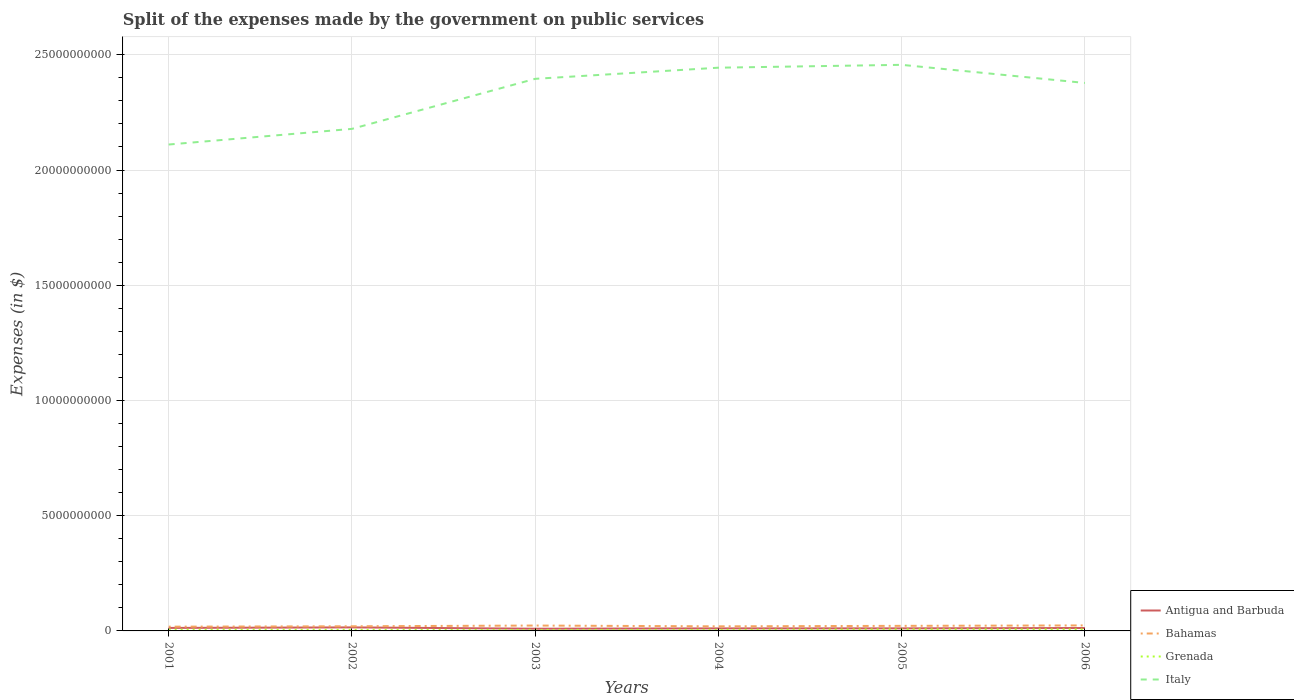Does the line corresponding to Grenada intersect with the line corresponding to Bahamas?
Offer a very short reply. No. Is the number of lines equal to the number of legend labels?
Offer a terse response. Yes. Across all years, what is the maximum expenses made by the government on public services in Grenada?
Offer a terse response. 4.05e+07. In which year was the expenses made by the government on public services in Italy maximum?
Give a very brief answer. 2001. What is the total expenses made by the government on public services in Bahamas in the graph?
Make the answer very short. -1.86e+07. What is the difference between the highest and the second highest expenses made by the government on public services in Antigua and Barbuda?
Your answer should be compact. 5.72e+07. Where does the legend appear in the graph?
Make the answer very short. Bottom right. How are the legend labels stacked?
Offer a very short reply. Vertical. What is the title of the graph?
Give a very brief answer. Split of the expenses made by the government on public services. Does "Lithuania" appear as one of the legend labels in the graph?
Offer a terse response. No. What is the label or title of the X-axis?
Make the answer very short. Years. What is the label or title of the Y-axis?
Ensure brevity in your answer.  Expenses (in $). What is the Expenses (in $) in Antigua and Barbuda in 2001?
Offer a terse response. 1.30e+08. What is the Expenses (in $) in Bahamas in 2001?
Keep it short and to the point. 1.85e+08. What is the Expenses (in $) in Grenada in 2001?
Your answer should be very brief. 5.26e+07. What is the Expenses (in $) in Italy in 2001?
Your answer should be compact. 2.11e+1. What is the Expenses (in $) in Antigua and Barbuda in 2002?
Your answer should be compact. 1.53e+08. What is the Expenses (in $) in Bahamas in 2002?
Keep it short and to the point. 2.02e+08. What is the Expenses (in $) of Grenada in 2002?
Make the answer very short. 4.75e+07. What is the Expenses (in $) of Italy in 2002?
Provide a succinct answer. 2.18e+1. What is the Expenses (in $) of Antigua and Barbuda in 2003?
Keep it short and to the point. 9.59e+07. What is the Expenses (in $) in Bahamas in 2003?
Offer a very short reply. 2.33e+08. What is the Expenses (in $) in Grenada in 2003?
Your response must be concise. 4.05e+07. What is the Expenses (in $) of Italy in 2003?
Offer a terse response. 2.40e+1. What is the Expenses (in $) in Antigua and Barbuda in 2004?
Your answer should be very brief. 1.10e+08. What is the Expenses (in $) of Bahamas in 2004?
Your answer should be very brief. 1.99e+08. What is the Expenses (in $) of Grenada in 2004?
Keep it short and to the point. 4.61e+07. What is the Expenses (in $) in Italy in 2004?
Keep it short and to the point. 2.44e+1. What is the Expenses (in $) in Antigua and Barbuda in 2005?
Provide a succinct answer. 1.11e+08. What is the Expenses (in $) in Bahamas in 2005?
Offer a very short reply. 2.20e+08. What is the Expenses (in $) in Grenada in 2005?
Offer a very short reply. 6.79e+07. What is the Expenses (in $) of Italy in 2005?
Your response must be concise. 2.46e+1. What is the Expenses (in $) of Antigua and Barbuda in 2006?
Ensure brevity in your answer.  1.26e+08. What is the Expenses (in $) of Bahamas in 2006?
Ensure brevity in your answer.  2.39e+08. What is the Expenses (in $) of Grenada in 2006?
Ensure brevity in your answer.  6.61e+07. What is the Expenses (in $) of Italy in 2006?
Ensure brevity in your answer.  2.38e+1. Across all years, what is the maximum Expenses (in $) in Antigua and Barbuda?
Ensure brevity in your answer.  1.53e+08. Across all years, what is the maximum Expenses (in $) of Bahamas?
Provide a succinct answer. 2.39e+08. Across all years, what is the maximum Expenses (in $) in Grenada?
Provide a succinct answer. 6.79e+07. Across all years, what is the maximum Expenses (in $) in Italy?
Offer a very short reply. 2.46e+1. Across all years, what is the minimum Expenses (in $) of Antigua and Barbuda?
Provide a short and direct response. 9.59e+07. Across all years, what is the minimum Expenses (in $) of Bahamas?
Your response must be concise. 1.85e+08. Across all years, what is the minimum Expenses (in $) of Grenada?
Provide a short and direct response. 4.05e+07. Across all years, what is the minimum Expenses (in $) of Italy?
Your response must be concise. 2.11e+1. What is the total Expenses (in $) in Antigua and Barbuda in the graph?
Provide a short and direct response. 7.26e+08. What is the total Expenses (in $) in Bahamas in the graph?
Your answer should be compact. 1.28e+09. What is the total Expenses (in $) of Grenada in the graph?
Keep it short and to the point. 3.21e+08. What is the total Expenses (in $) in Italy in the graph?
Give a very brief answer. 1.40e+11. What is the difference between the Expenses (in $) in Antigua and Barbuda in 2001 and that in 2002?
Give a very brief answer. -2.31e+07. What is the difference between the Expenses (in $) in Bahamas in 2001 and that in 2002?
Your response must be concise. -1.67e+07. What is the difference between the Expenses (in $) of Grenada in 2001 and that in 2002?
Give a very brief answer. 5.10e+06. What is the difference between the Expenses (in $) in Italy in 2001 and that in 2002?
Make the answer very short. -6.79e+08. What is the difference between the Expenses (in $) of Antigua and Barbuda in 2001 and that in 2003?
Your answer should be compact. 3.41e+07. What is the difference between the Expenses (in $) in Bahamas in 2001 and that in 2003?
Provide a short and direct response. -4.84e+07. What is the difference between the Expenses (in $) in Grenada in 2001 and that in 2003?
Your answer should be very brief. 1.21e+07. What is the difference between the Expenses (in $) in Italy in 2001 and that in 2003?
Offer a terse response. -2.85e+09. What is the difference between the Expenses (in $) of Antigua and Barbuda in 2001 and that in 2004?
Your response must be concise. 2.01e+07. What is the difference between the Expenses (in $) in Bahamas in 2001 and that in 2004?
Provide a succinct answer. -1.43e+07. What is the difference between the Expenses (in $) of Grenada in 2001 and that in 2004?
Your answer should be very brief. 6.50e+06. What is the difference between the Expenses (in $) in Italy in 2001 and that in 2004?
Your answer should be compact. -3.33e+09. What is the difference between the Expenses (in $) in Antigua and Barbuda in 2001 and that in 2005?
Your response must be concise. 1.90e+07. What is the difference between the Expenses (in $) in Bahamas in 2001 and that in 2005?
Make the answer very short. -3.53e+07. What is the difference between the Expenses (in $) of Grenada in 2001 and that in 2005?
Make the answer very short. -1.53e+07. What is the difference between the Expenses (in $) in Italy in 2001 and that in 2005?
Offer a terse response. -3.46e+09. What is the difference between the Expenses (in $) in Antigua and Barbuda in 2001 and that in 2006?
Offer a terse response. 3.80e+06. What is the difference between the Expenses (in $) in Bahamas in 2001 and that in 2006?
Offer a very short reply. -5.38e+07. What is the difference between the Expenses (in $) in Grenada in 2001 and that in 2006?
Your answer should be very brief. -1.35e+07. What is the difference between the Expenses (in $) in Italy in 2001 and that in 2006?
Make the answer very short. -2.67e+09. What is the difference between the Expenses (in $) in Antigua and Barbuda in 2002 and that in 2003?
Provide a short and direct response. 5.72e+07. What is the difference between the Expenses (in $) of Bahamas in 2002 and that in 2003?
Make the answer very short. -3.17e+07. What is the difference between the Expenses (in $) of Grenada in 2002 and that in 2003?
Ensure brevity in your answer.  7.00e+06. What is the difference between the Expenses (in $) of Italy in 2002 and that in 2003?
Your answer should be compact. -2.17e+09. What is the difference between the Expenses (in $) of Antigua and Barbuda in 2002 and that in 2004?
Keep it short and to the point. 4.32e+07. What is the difference between the Expenses (in $) of Bahamas in 2002 and that in 2004?
Your answer should be very brief. 2.43e+06. What is the difference between the Expenses (in $) of Grenada in 2002 and that in 2004?
Ensure brevity in your answer.  1.40e+06. What is the difference between the Expenses (in $) of Italy in 2002 and that in 2004?
Your response must be concise. -2.66e+09. What is the difference between the Expenses (in $) in Antigua and Barbuda in 2002 and that in 2005?
Provide a short and direct response. 4.21e+07. What is the difference between the Expenses (in $) in Bahamas in 2002 and that in 2005?
Your answer should be very brief. -1.86e+07. What is the difference between the Expenses (in $) of Grenada in 2002 and that in 2005?
Keep it short and to the point. -2.04e+07. What is the difference between the Expenses (in $) in Italy in 2002 and that in 2005?
Offer a terse response. -2.78e+09. What is the difference between the Expenses (in $) of Antigua and Barbuda in 2002 and that in 2006?
Offer a terse response. 2.69e+07. What is the difference between the Expenses (in $) in Bahamas in 2002 and that in 2006?
Your response must be concise. -3.71e+07. What is the difference between the Expenses (in $) in Grenada in 2002 and that in 2006?
Ensure brevity in your answer.  -1.86e+07. What is the difference between the Expenses (in $) of Italy in 2002 and that in 2006?
Provide a short and direct response. -1.99e+09. What is the difference between the Expenses (in $) of Antigua and Barbuda in 2003 and that in 2004?
Your response must be concise. -1.40e+07. What is the difference between the Expenses (in $) in Bahamas in 2003 and that in 2004?
Offer a terse response. 3.41e+07. What is the difference between the Expenses (in $) in Grenada in 2003 and that in 2004?
Your answer should be very brief. -5.60e+06. What is the difference between the Expenses (in $) in Italy in 2003 and that in 2004?
Offer a very short reply. -4.83e+08. What is the difference between the Expenses (in $) in Antigua and Barbuda in 2003 and that in 2005?
Give a very brief answer. -1.51e+07. What is the difference between the Expenses (in $) of Bahamas in 2003 and that in 2005?
Your response must be concise. 1.31e+07. What is the difference between the Expenses (in $) of Grenada in 2003 and that in 2005?
Ensure brevity in your answer.  -2.74e+07. What is the difference between the Expenses (in $) in Italy in 2003 and that in 2005?
Offer a very short reply. -6.07e+08. What is the difference between the Expenses (in $) in Antigua and Barbuda in 2003 and that in 2006?
Keep it short and to the point. -3.03e+07. What is the difference between the Expenses (in $) in Bahamas in 2003 and that in 2006?
Your response must be concise. -5.39e+06. What is the difference between the Expenses (in $) of Grenada in 2003 and that in 2006?
Make the answer very short. -2.56e+07. What is the difference between the Expenses (in $) of Italy in 2003 and that in 2006?
Keep it short and to the point. 1.79e+08. What is the difference between the Expenses (in $) in Antigua and Barbuda in 2004 and that in 2005?
Give a very brief answer. -1.10e+06. What is the difference between the Expenses (in $) of Bahamas in 2004 and that in 2005?
Make the answer very short. -2.10e+07. What is the difference between the Expenses (in $) of Grenada in 2004 and that in 2005?
Your answer should be very brief. -2.18e+07. What is the difference between the Expenses (in $) in Italy in 2004 and that in 2005?
Make the answer very short. -1.24e+08. What is the difference between the Expenses (in $) of Antigua and Barbuda in 2004 and that in 2006?
Ensure brevity in your answer.  -1.63e+07. What is the difference between the Expenses (in $) in Bahamas in 2004 and that in 2006?
Ensure brevity in your answer.  -3.95e+07. What is the difference between the Expenses (in $) in Grenada in 2004 and that in 2006?
Your answer should be compact. -2.00e+07. What is the difference between the Expenses (in $) in Italy in 2004 and that in 2006?
Your response must be concise. 6.62e+08. What is the difference between the Expenses (in $) in Antigua and Barbuda in 2005 and that in 2006?
Give a very brief answer. -1.52e+07. What is the difference between the Expenses (in $) of Bahamas in 2005 and that in 2006?
Your answer should be compact. -1.85e+07. What is the difference between the Expenses (in $) in Grenada in 2005 and that in 2006?
Your answer should be compact. 1.80e+06. What is the difference between the Expenses (in $) of Italy in 2005 and that in 2006?
Provide a short and direct response. 7.86e+08. What is the difference between the Expenses (in $) in Antigua and Barbuda in 2001 and the Expenses (in $) in Bahamas in 2002?
Your answer should be compact. -7.15e+07. What is the difference between the Expenses (in $) in Antigua and Barbuda in 2001 and the Expenses (in $) in Grenada in 2002?
Provide a succinct answer. 8.25e+07. What is the difference between the Expenses (in $) in Antigua and Barbuda in 2001 and the Expenses (in $) in Italy in 2002?
Ensure brevity in your answer.  -2.17e+1. What is the difference between the Expenses (in $) in Bahamas in 2001 and the Expenses (in $) in Grenada in 2002?
Provide a succinct answer. 1.37e+08. What is the difference between the Expenses (in $) of Bahamas in 2001 and the Expenses (in $) of Italy in 2002?
Your answer should be very brief. -2.16e+1. What is the difference between the Expenses (in $) of Grenada in 2001 and the Expenses (in $) of Italy in 2002?
Offer a very short reply. -2.17e+1. What is the difference between the Expenses (in $) of Antigua and Barbuda in 2001 and the Expenses (in $) of Bahamas in 2003?
Offer a very short reply. -1.03e+08. What is the difference between the Expenses (in $) of Antigua and Barbuda in 2001 and the Expenses (in $) of Grenada in 2003?
Provide a short and direct response. 8.95e+07. What is the difference between the Expenses (in $) of Antigua and Barbuda in 2001 and the Expenses (in $) of Italy in 2003?
Your answer should be very brief. -2.38e+1. What is the difference between the Expenses (in $) in Bahamas in 2001 and the Expenses (in $) in Grenada in 2003?
Offer a very short reply. 1.44e+08. What is the difference between the Expenses (in $) in Bahamas in 2001 and the Expenses (in $) in Italy in 2003?
Offer a terse response. -2.38e+1. What is the difference between the Expenses (in $) of Grenada in 2001 and the Expenses (in $) of Italy in 2003?
Your answer should be very brief. -2.39e+1. What is the difference between the Expenses (in $) of Antigua and Barbuda in 2001 and the Expenses (in $) of Bahamas in 2004?
Your response must be concise. -6.91e+07. What is the difference between the Expenses (in $) in Antigua and Barbuda in 2001 and the Expenses (in $) in Grenada in 2004?
Your response must be concise. 8.39e+07. What is the difference between the Expenses (in $) of Antigua and Barbuda in 2001 and the Expenses (in $) of Italy in 2004?
Ensure brevity in your answer.  -2.43e+1. What is the difference between the Expenses (in $) in Bahamas in 2001 and the Expenses (in $) in Grenada in 2004?
Ensure brevity in your answer.  1.39e+08. What is the difference between the Expenses (in $) in Bahamas in 2001 and the Expenses (in $) in Italy in 2004?
Ensure brevity in your answer.  -2.43e+1. What is the difference between the Expenses (in $) in Grenada in 2001 and the Expenses (in $) in Italy in 2004?
Keep it short and to the point. -2.44e+1. What is the difference between the Expenses (in $) of Antigua and Barbuda in 2001 and the Expenses (in $) of Bahamas in 2005?
Offer a terse response. -9.01e+07. What is the difference between the Expenses (in $) of Antigua and Barbuda in 2001 and the Expenses (in $) of Grenada in 2005?
Keep it short and to the point. 6.21e+07. What is the difference between the Expenses (in $) in Antigua and Barbuda in 2001 and the Expenses (in $) in Italy in 2005?
Your answer should be compact. -2.44e+1. What is the difference between the Expenses (in $) of Bahamas in 2001 and the Expenses (in $) of Grenada in 2005?
Make the answer very short. 1.17e+08. What is the difference between the Expenses (in $) in Bahamas in 2001 and the Expenses (in $) in Italy in 2005?
Offer a terse response. -2.44e+1. What is the difference between the Expenses (in $) of Grenada in 2001 and the Expenses (in $) of Italy in 2005?
Offer a terse response. -2.45e+1. What is the difference between the Expenses (in $) in Antigua and Barbuda in 2001 and the Expenses (in $) in Bahamas in 2006?
Your answer should be very brief. -1.09e+08. What is the difference between the Expenses (in $) in Antigua and Barbuda in 2001 and the Expenses (in $) in Grenada in 2006?
Give a very brief answer. 6.39e+07. What is the difference between the Expenses (in $) of Antigua and Barbuda in 2001 and the Expenses (in $) of Italy in 2006?
Keep it short and to the point. -2.36e+1. What is the difference between the Expenses (in $) of Bahamas in 2001 and the Expenses (in $) of Grenada in 2006?
Provide a short and direct response. 1.19e+08. What is the difference between the Expenses (in $) of Bahamas in 2001 and the Expenses (in $) of Italy in 2006?
Keep it short and to the point. -2.36e+1. What is the difference between the Expenses (in $) in Grenada in 2001 and the Expenses (in $) in Italy in 2006?
Make the answer very short. -2.37e+1. What is the difference between the Expenses (in $) of Antigua and Barbuda in 2002 and the Expenses (in $) of Bahamas in 2003?
Your answer should be compact. -8.01e+07. What is the difference between the Expenses (in $) in Antigua and Barbuda in 2002 and the Expenses (in $) in Grenada in 2003?
Ensure brevity in your answer.  1.13e+08. What is the difference between the Expenses (in $) in Antigua and Barbuda in 2002 and the Expenses (in $) in Italy in 2003?
Provide a short and direct response. -2.38e+1. What is the difference between the Expenses (in $) of Bahamas in 2002 and the Expenses (in $) of Grenada in 2003?
Your answer should be very brief. 1.61e+08. What is the difference between the Expenses (in $) of Bahamas in 2002 and the Expenses (in $) of Italy in 2003?
Make the answer very short. -2.38e+1. What is the difference between the Expenses (in $) in Grenada in 2002 and the Expenses (in $) in Italy in 2003?
Provide a succinct answer. -2.39e+1. What is the difference between the Expenses (in $) in Antigua and Barbuda in 2002 and the Expenses (in $) in Bahamas in 2004?
Your answer should be compact. -4.60e+07. What is the difference between the Expenses (in $) of Antigua and Barbuda in 2002 and the Expenses (in $) of Grenada in 2004?
Your response must be concise. 1.07e+08. What is the difference between the Expenses (in $) in Antigua and Barbuda in 2002 and the Expenses (in $) in Italy in 2004?
Provide a short and direct response. -2.43e+1. What is the difference between the Expenses (in $) in Bahamas in 2002 and the Expenses (in $) in Grenada in 2004?
Your response must be concise. 1.55e+08. What is the difference between the Expenses (in $) in Bahamas in 2002 and the Expenses (in $) in Italy in 2004?
Keep it short and to the point. -2.42e+1. What is the difference between the Expenses (in $) in Grenada in 2002 and the Expenses (in $) in Italy in 2004?
Your answer should be compact. -2.44e+1. What is the difference between the Expenses (in $) in Antigua and Barbuda in 2002 and the Expenses (in $) in Bahamas in 2005?
Your response must be concise. -6.70e+07. What is the difference between the Expenses (in $) of Antigua and Barbuda in 2002 and the Expenses (in $) of Grenada in 2005?
Provide a succinct answer. 8.52e+07. What is the difference between the Expenses (in $) in Antigua and Barbuda in 2002 and the Expenses (in $) in Italy in 2005?
Provide a succinct answer. -2.44e+1. What is the difference between the Expenses (in $) of Bahamas in 2002 and the Expenses (in $) of Grenada in 2005?
Ensure brevity in your answer.  1.34e+08. What is the difference between the Expenses (in $) of Bahamas in 2002 and the Expenses (in $) of Italy in 2005?
Offer a very short reply. -2.44e+1. What is the difference between the Expenses (in $) in Grenada in 2002 and the Expenses (in $) in Italy in 2005?
Make the answer very short. -2.45e+1. What is the difference between the Expenses (in $) in Antigua and Barbuda in 2002 and the Expenses (in $) in Bahamas in 2006?
Provide a succinct answer. -8.55e+07. What is the difference between the Expenses (in $) of Antigua and Barbuda in 2002 and the Expenses (in $) of Grenada in 2006?
Your answer should be compact. 8.70e+07. What is the difference between the Expenses (in $) in Antigua and Barbuda in 2002 and the Expenses (in $) in Italy in 2006?
Offer a terse response. -2.36e+1. What is the difference between the Expenses (in $) in Bahamas in 2002 and the Expenses (in $) in Grenada in 2006?
Provide a succinct answer. 1.35e+08. What is the difference between the Expenses (in $) of Bahamas in 2002 and the Expenses (in $) of Italy in 2006?
Provide a short and direct response. -2.36e+1. What is the difference between the Expenses (in $) of Grenada in 2002 and the Expenses (in $) of Italy in 2006?
Offer a terse response. -2.37e+1. What is the difference between the Expenses (in $) of Antigua and Barbuda in 2003 and the Expenses (in $) of Bahamas in 2004?
Offer a terse response. -1.03e+08. What is the difference between the Expenses (in $) in Antigua and Barbuda in 2003 and the Expenses (in $) in Grenada in 2004?
Offer a terse response. 4.98e+07. What is the difference between the Expenses (in $) of Antigua and Barbuda in 2003 and the Expenses (in $) of Italy in 2004?
Offer a terse response. -2.43e+1. What is the difference between the Expenses (in $) of Bahamas in 2003 and the Expenses (in $) of Grenada in 2004?
Your response must be concise. 1.87e+08. What is the difference between the Expenses (in $) in Bahamas in 2003 and the Expenses (in $) in Italy in 2004?
Your answer should be very brief. -2.42e+1. What is the difference between the Expenses (in $) in Grenada in 2003 and the Expenses (in $) in Italy in 2004?
Provide a succinct answer. -2.44e+1. What is the difference between the Expenses (in $) in Antigua and Barbuda in 2003 and the Expenses (in $) in Bahamas in 2005?
Your answer should be very brief. -1.24e+08. What is the difference between the Expenses (in $) of Antigua and Barbuda in 2003 and the Expenses (in $) of Grenada in 2005?
Offer a very short reply. 2.80e+07. What is the difference between the Expenses (in $) in Antigua and Barbuda in 2003 and the Expenses (in $) in Italy in 2005?
Your response must be concise. -2.45e+1. What is the difference between the Expenses (in $) of Bahamas in 2003 and the Expenses (in $) of Grenada in 2005?
Make the answer very short. 1.65e+08. What is the difference between the Expenses (in $) of Bahamas in 2003 and the Expenses (in $) of Italy in 2005?
Ensure brevity in your answer.  -2.43e+1. What is the difference between the Expenses (in $) in Grenada in 2003 and the Expenses (in $) in Italy in 2005?
Your response must be concise. -2.45e+1. What is the difference between the Expenses (in $) in Antigua and Barbuda in 2003 and the Expenses (in $) in Bahamas in 2006?
Your response must be concise. -1.43e+08. What is the difference between the Expenses (in $) in Antigua and Barbuda in 2003 and the Expenses (in $) in Grenada in 2006?
Make the answer very short. 2.98e+07. What is the difference between the Expenses (in $) of Antigua and Barbuda in 2003 and the Expenses (in $) of Italy in 2006?
Your answer should be compact. -2.37e+1. What is the difference between the Expenses (in $) in Bahamas in 2003 and the Expenses (in $) in Grenada in 2006?
Keep it short and to the point. 1.67e+08. What is the difference between the Expenses (in $) in Bahamas in 2003 and the Expenses (in $) in Italy in 2006?
Offer a very short reply. -2.35e+1. What is the difference between the Expenses (in $) in Grenada in 2003 and the Expenses (in $) in Italy in 2006?
Offer a very short reply. -2.37e+1. What is the difference between the Expenses (in $) of Antigua and Barbuda in 2004 and the Expenses (in $) of Bahamas in 2005?
Your answer should be very brief. -1.10e+08. What is the difference between the Expenses (in $) in Antigua and Barbuda in 2004 and the Expenses (in $) in Grenada in 2005?
Your response must be concise. 4.20e+07. What is the difference between the Expenses (in $) in Antigua and Barbuda in 2004 and the Expenses (in $) in Italy in 2005?
Give a very brief answer. -2.45e+1. What is the difference between the Expenses (in $) in Bahamas in 2004 and the Expenses (in $) in Grenada in 2005?
Your answer should be compact. 1.31e+08. What is the difference between the Expenses (in $) of Bahamas in 2004 and the Expenses (in $) of Italy in 2005?
Provide a short and direct response. -2.44e+1. What is the difference between the Expenses (in $) of Grenada in 2004 and the Expenses (in $) of Italy in 2005?
Ensure brevity in your answer.  -2.45e+1. What is the difference between the Expenses (in $) in Antigua and Barbuda in 2004 and the Expenses (in $) in Bahamas in 2006?
Provide a short and direct response. -1.29e+08. What is the difference between the Expenses (in $) in Antigua and Barbuda in 2004 and the Expenses (in $) in Grenada in 2006?
Provide a succinct answer. 4.38e+07. What is the difference between the Expenses (in $) in Antigua and Barbuda in 2004 and the Expenses (in $) in Italy in 2006?
Provide a short and direct response. -2.37e+1. What is the difference between the Expenses (in $) of Bahamas in 2004 and the Expenses (in $) of Grenada in 2006?
Offer a terse response. 1.33e+08. What is the difference between the Expenses (in $) in Bahamas in 2004 and the Expenses (in $) in Italy in 2006?
Ensure brevity in your answer.  -2.36e+1. What is the difference between the Expenses (in $) in Grenada in 2004 and the Expenses (in $) in Italy in 2006?
Provide a short and direct response. -2.37e+1. What is the difference between the Expenses (in $) of Antigua and Barbuda in 2005 and the Expenses (in $) of Bahamas in 2006?
Offer a very short reply. -1.28e+08. What is the difference between the Expenses (in $) in Antigua and Barbuda in 2005 and the Expenses (in $) in Grenada in 2006?
Make the answer very short. 4.49e+07. What is the difference between the Expenses (in $) in Antigua and Barbuda in 2005 and the Expenses (in $) in Italy in 2006?
Ensure brevity in your answer.  -2.37e+1. What is the difference between the Expenses (in $) of Bahamas in 2005 and the Expenses (in $) of Grenada in 2006?
Keep it short and to the point. 1.54e+08. What is the difference between the Expenses (in $) in Bahamas in 2005 and the Expenses (in $) in Italy in 2006?
Offer a terse response. -2.36e+1. What is the difference between the Expenses (in $) in Grenada in 2005 and the Expenses (in $) in Italy in 2006?
Your answer should be compact. -2.37e+1. What is the average Expenses (in $) of Antigua and Barbuda per year?
Provide a succinct answer. 1.21e+08. What is the average Expenses (in $) in Bahamas per year?
Offer a very short reply. 2.13e+08. What is the average Expenses (in $) in Grenada per year?
Keep it short and to the point. 5.34e+07. What is the average Expenses (in $) of Italy per year?
Ensure brevity in your answer.  2.33e+1. In the year 2001, what is the difference between the Expenses (in $) of Antigua and Barbuda and Expenses (in $) of Bahamas?
Provide a succinct answer. -5.48e+07. In the year 2001, what is the difference between the Expenses (in $) in Antigua and Barbuda and Expenses (in $) in Grenada?
Your answer should be very brief. 7.74e+07. In the year 2001, what is the difference between the Expenses (in $) of Antigua and Barbuda and Expenses (in $) of Italy?
Provide a succinct answer. -2.10e+1. In the year 2001, what is the difference between the Expenses (in $) of Bahamas and Expenses (in $) of Grenada?
Give a very brief answer. 1.32e+08. In the year 2001, what is the difference between the Expenses (in $) of Bahamas and Expenses (in $) of Italy?
Make the answer very short. -2.09e+1. In the year 2001, what is the difference between the Expenses (in $) of Grenada and Expenses (in $) of Italy?
Give a very brief answer. -2.11e+1. In the year 2002, what is the difference between the Expenses (in $) in Antigua and Barbuda and Expenses (in $) in Bahamas?
Ensure brevity in your answer.  -4.84e+07. In the year 2002, what is the difference between the Expenses (in $) in Antigua and Barbuda and Expenses (in $) in Grenada?
Provide a succinct answer. 1.06e+08. In the year 2002, what is the difference between the Expenses (in $) of Antigua and Barbuda and Expenses (in $) of Italy?
Offer a terse response. -2.16e+1. In the year 2002, what is the difference between the Expenses (in $) in Bahamas and Expenses (in $) in Grenada?
Provide a short and direct response. 1.54e+08. In the year 2002, what is the difference between the Expenses (in $) in Bahamas and Expenses (in $) in Italy?
Keep it short and to the point. -2.16e+1. In the year 2002, what is the difference between the Expenses (in $) of Grenada and Expenses (in $) of Italy?
Offer a very short reply. -2.17e+1. In the year 2003, what is the difference between the Expenses (in $) of Antigua and Barbuda and Expenses (in $) of Bahamas?
Your response must be concise. -1.37e+08. In the year 2003, what is the difference between the Expenses (in $) of Antigua and Barbuda and Expenses (in $) of Grenada?
Offer a terse response. 5.54e+07. In the year 2003, what is the difference between the Expenses (in $) of Antigua and Barbuda and Expenses (in $) of Italy?
Ensure brevity in your answer.  -2.39e+1. In the year 2003, what is the difference between the Expenses (in $) of Bahamas and Expenses (in $) of Grenada?
Ensure brevity in your answer.  1.93e+08. In the year 2003, what is the difference between the Expenses (in $) of Bahamas and Expenses (in $) of Italy?
Offer a very short reply. -2.37e+1. In the year 2003, what is the difference between the Expenses (in $) in Grenada and Expenses (in $) in Italy?
Offer a terse response. -2.39e+1. In the year 2004, what is the difference between the Expenses (in $) of Antigua and Barbuda and Expenses (in $) of Bahamas?
Keep it short and to the point. -8.92e+07. In the year 2004, what is the difference between the Expenses (in $) of Antigua and Barbuda and Expenses (in $) of Grenada?
Your answer should be very brief. 6.38e+07. In the year 2004, what is the difference between the Expenses (in $) in Antigua and Barbuda and Expenses (in $) in Italy?
Provide a succinct answer. -2.43e+1. In the year 2004, what is the difference between the Expenses (in $) in Bahamas and Expenses (in $) in Grenada?
Offer a very short reply. 1.53e+08. In the year 2004, what is the difference between the Expenses (in $) in Bahamas and Expenses (in $) in Italy?
Ensure brevity in your answer.  -2.42e+1. In the year 2004, what is the difference between the Expenses (in $) in Grenada and Expenses (in $) in Italy?
Offer a terse response. -2.44e+1. In the year 2005, what is the difference between the Expenses (in $) of Antigua and Barbuda and Expenses (in $) of Bahamas?
Make the answer very short. -1.09e+08. In the year 2005, what is the difference between the Expenses (in $) of Antigua and Barbuda and Expenses (in $) of Grenada?
Your response must be concise. 4.31e+07. In the year 2005, what is the difference between the Expenses (in $) of Antigua and Barbuda and Expenses (in $) of Italy?
Offer a terse response. -2.45e+1. In the year 2005, what is the difference between the Expenses (in $) of Bahamas and Expenses (in $) of Grenada?
Ensure brevity in your answer.  1.52e+08. In the year 2005, what is the difference between the Expenses (in $) in Bahamas and Expenses (in $) in Italy?
Ensure brevity in your answer.  -2.43e+1. In the year 2005, what is the difference between the Expenses (in $) in Grenada and Expenses (in $) in Italy?
Keep it short and to the point. -2.45e+1. In the year 2006, what is the difference between the Expenses (in $) of Antigua and Barbuda and Expenses (in $) of Bahamas?
Your answer should be compact. -1.12e+08. In the year 2006, what is the difference between the Expenses (in $) in Antigua and Barbuda and Expenses (in $) in Grenada?
Your response must be concise. 6.01e+07. In the year 2006, what is the difference between the Expenses (in $) in Antigua and Barbuda and Expenses (in $) in Italy?
Your response must be concise. -2.37e+1. In the year 2006, what is the difference between the Expenses (in $) of Bahamas and Expenses (in $) of Grenada?
Provide a short and direct response. 1.72e+08. In the year 2006, what is the difference between the Expenses (in $) of Bahamas and Expenses (in $) of Italy?
Give a very brief answer. -2.35e+1. In the year 2006, what is the difference between the Expenses (in $) in Grenada and Expenses (in $) in Italy?
Your answer should be very brief. -2.37e+1. What is the ratio of the Expenses (in $) of Antigua and Barbuda in 2001 to that in 2002?
Offer a very short reply. 0.85. What is the ratio of the Expenses (in $) in Bahamas in 2001 to that in 2002?
Make the answer very short. 0.92. What is the ratio of the Expenses (in $) in Grenada in 2001 to that in 2002?
Provide a succinct answer. 1.11. What is the ratio of the Expenses (in $) in Italy in 2001 to that in 2002?
Your answer should be compact. 0.97. What is the ratio of the Expenses (in $) of Antigua and Barbuda in 2001 to that in 2003?
Your answer should be very brief. 1.36. What is the ratio of the Expenses (in $) of Bahamas in 2001 to that in 2003?
Keep it short and to the point. 0.79. What is the ratio of the Expenses (in $) of Grenada in 2001 to that in 2003?
Keep it short and to the point. 1.3. What is the ratio of the Expenses (in $) of Italy in 2001 to that in 2003?
Your response must be concise. 0.88. What is the ratio of the Expenses (in $) in Antigua and Barbuda in 2001 to that in 2004?
Your answer should be very brief. 1.18. What is the ratio of the Expenses (in $) in Bahamas in 2001 to that in 2004?
Provide a succinct answer. 0.93. What is the ratio of the Expenses (in $) of Grenada in 2001 to that in 2004?
Your answer should be very brief. 1.14. What is the ratio of the Expenses (in $) in Italy in 2001 to that in 2004?
Give a very brief answer. 0.86. What is the ratio of the Expenses (in $) in Antigua and Barbuda in 2001 to that in 2005?
Your response must be concise. 1.17. What is the ratio of the Expenses (in $) of Bahamas in 2001 to that in 2005?
Provide a succinct answer. 0.84. What is the ratio of the Expenses (in $) in Grenada in 2001 to that in 2005?
Your response must be concise. 0.77. What is the ratio of the Expenses (in $) in Italy in 2001 to that in 2005?
Offer a very short reply. 0.86. What is the ratio of the Expenses (in $) in Antigua and Barbuda in 2001 to that in 2006?
Offer a terse response. 1.03. What is the ratio of the Expenses (in $) of Bahamas in 2001 to that in 2006?
Provide a short and direct response. 0.77. What is the ratio of the Expenses (in $) of Grenada in 2001 to that in 2006?
Provide a succinct answer. 0.8. What is the ratio of the Expenses (in $) of Italy in 2001 to that in 2006?
Offer a terse response. 0.89. What is the ratio of the Expenses (in $) in Antigua and Barbuda in 2002 to that in 2003?
Offer a terse response. 1.6. What is the ratio of the Expenses (in $) in Bahamas in 2002 to that in 2003?
Provide a succinct answer. 0.86. What is the ratio of the Expenses (in $) of Grenada in 2002 to that in 2003?
Provide a succinct answer. 1.17. What is the ratio of the Expenses (in $) in Italy in 2002 to that in 2003?
Give a very brief answer. 0.91. What is the ratio of the Expenses (in $) of Antigua and Barbuda in 2002 to that in 2004?
Offer a terse response. 1.39. What is the ratio of the Expenses (in $) of Bahamas in 2002 to that in 2004?
Offer a terse response. 1.01. What is the ratio of the Expenses (in $) in Grenada in 2002 to that in 2004?
Offer a terse response. 1.03. What is the ratio of the Expenses (in $) in Italy in 2002 to that in 2004?
Offer a very short reply. 0.89. What is the ratio of the Expenses (in $) of Antigua and Barbuda in 2002 to that in 2005?
Your response must be concise. 1.38. What is the ratio of the Expenses (in $) in Bahamas in 2002 to that in 2005?
Provide a short and direct response. 0.92. What is the ratio of the Expenses (in $) in Grenada in 2002 to that in 2005?
Keep it short and to the point. 0.7. What is the ratio of the Expenses (in $) of Italy in 2002 to that in 2005?
Offer a very short reply. 0.89. What is the ratio of the Expenses (in $) in Antigua and Barbuda in 2002 to that in 2006?
Ensure brevity in your answer.  1.21. What is the ratio of the Expenses (in $) in Bahamas in 2002 to that in 2006?
Your response must be concise. 0.84. What is the ratio of the Expenses (in $) in Grenada in 2002 to that in 2006?
Provide a succinct answer. 0.72. What is the ratio of the Expenses (in $) in Italy in 2002 to that in 2006?
Your answer should be very brief. 0.92. What is the ratio of the Expenses (in $) of Antigua and Barbuda in 2003 to that in 2004?
Offer a very short reply. 0.87. What is the ratio of the Expenses (in $) in Bahamas in 2003 to that in 2004?
Your response must be concise. 1.17. What is the ratio of the Expenses (in $) of Grenada in 2003 to that in 2004?
Your answer should be compact. 0.88. What is the ratio of the Expenses (in $) in Italy in 2003 to that in 2004?
Give a very brief answer. 0.98. What is the ratio of the Expenses (in $) of Antigua and Barbuda in 2003 to that in 2005?
Give a very brief answer. 0.86. What is the ratio of the Expenses (in $) in Bahamas in 2003 to that in 2005?
Provide a succinct answer. 1.06. What is the ratio of the Expenses (in $) in Grenada in 2003 to that in 2005?
Make the answer very short. 0.6. What is the ratio of the Expenses (in $) in Italy in 2003 to that in 2005?
Ensure brevity in your answer.  0.98. What is the ratio of the Expenses (in $) of Antigua and Barbuda in 2003 to that in 2006?
Offer a terse response. 0.76. What is the ratio of the Expenses (in $) in Bahamas in 2003 to that in 2006?
Make the answer very short. 0.98. What is the ratio of the Expenses (in $) of Grenada in 2003 to that in 2006?
Your answer should be compact. 0.61. What is the ratio of the Expenses (in $) in Italy in 2003 to that in 2006?
Keep it short and to the point. 1.01. What is the ratio of the Expenses (in $) of Antigua and Barbuda in 2004 to that in 2005?
Offer a very short reply. 0.99. What is the ratio of the Expenses (in $) of Bahamas in 2004 to that in 2005?
Your answer should be compact. 0.9. What is the ratio of the Expenses (in $) in Grenada in 2004 to that in 2005?
Provide a succinct answer. 0.68. What is the ratio of the Expenses (in $) in Italy in 2004 to that in 2005?
Make the answer very short. 0.99. What is the ratio of the Expenses (in $) of Antigua and Barbuda in 2004 to that in 2006?
Offer a very short reply. 0.87. What is the ratio of the Expenses (in $) in Bahamas in 2004 to that in 2006?
Your answer should be very brief. 0.83. What is the ratio of the Expenses (in $) in Grenada in 2004 to that in 2006?
Keep it short and to the point. 0.7. What is the ratio of the Expenses (in $) of Italy in 2004 to that in 2006?
Offer a very short reply. 1.03. What is the ratio of the Expenses (in $) of Antigua and Barbuda in 2005 to that in 2006?
Your answer should be compact. 0.88. What is the ratio of the Expenses (in $) of Bahamas in 2005 to that in 2006?
Your answer should be compact. 0.92. What is the ratio of the Expenses (in $) in Grenada in 2005 to that in 2006?
Your answer should be compact. 1.03. What is the ratio of the Expenses (in $) of Italy in 2005 to that in 2006?
Your response must be concise. 1.03. What is the difference between the highest and the second highest Expenses (in $) of Antigua and Barbuda?
Provide a succinct answer. 2.31e+07. What is the difference between the highest and the second highest Expenses (in $) of Bahamas?
Provide a short and direct response. 5.39e+06. What is the difference between the highest and the second highest Expenses (in $) of Grenada?
Give a very brief answer. 1.80e+06. What is the difference between the highest and the second highest Expenses (in $) in Italy?
Your response must be concise. 1.24e+08. What is the difference between the highest and the lowest Expenses (in $) of Antigua and Barbuda?
Provide a short and direct response. 5.72e+07. What is the difference between the highest and the lowest Expenses (in $) of Bahamas?
Offer a terse response. 5.38e+07. What is the difference between the highest and the lowest Expenses (in $) in Grenada?
Provide a succinct answer. 2.74e+07. What is the difference between the highest and the lowest Expenses (in $) in Italy?
Your answer should be compact. 3.46e+09. 